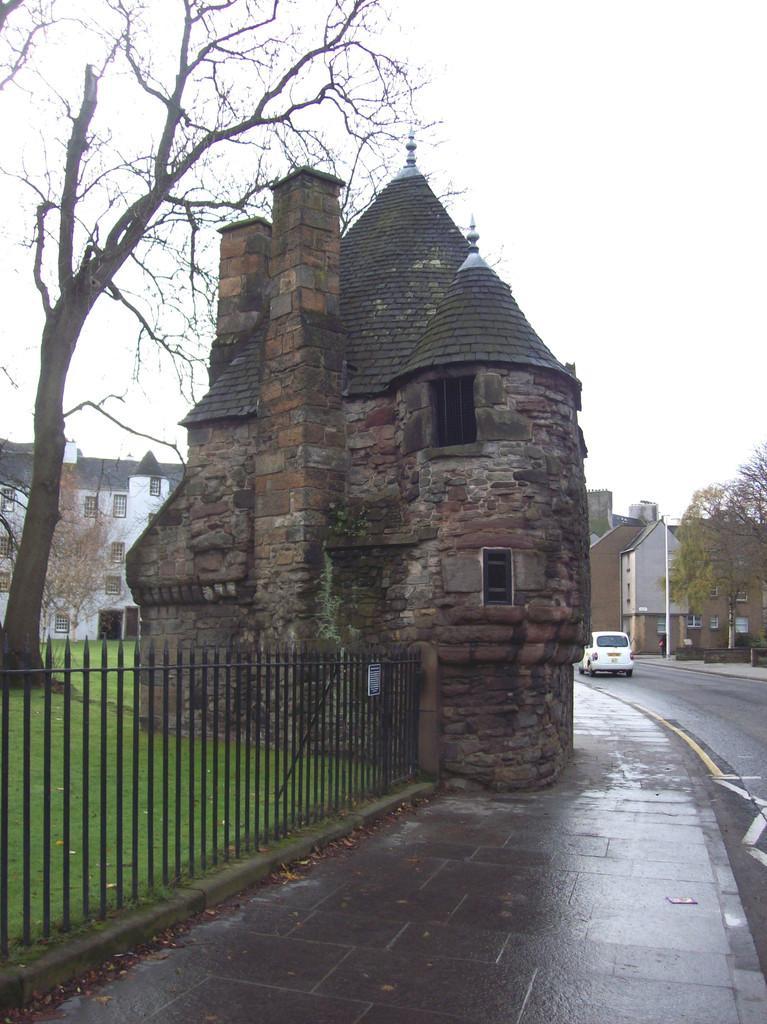Could you give a brief overview of what you see in this image? In the image there is a small castle in the middle, beside a grassland with a fence in front of it on right side, there is a car going on the road and in the background there are buildings and above its sky. 